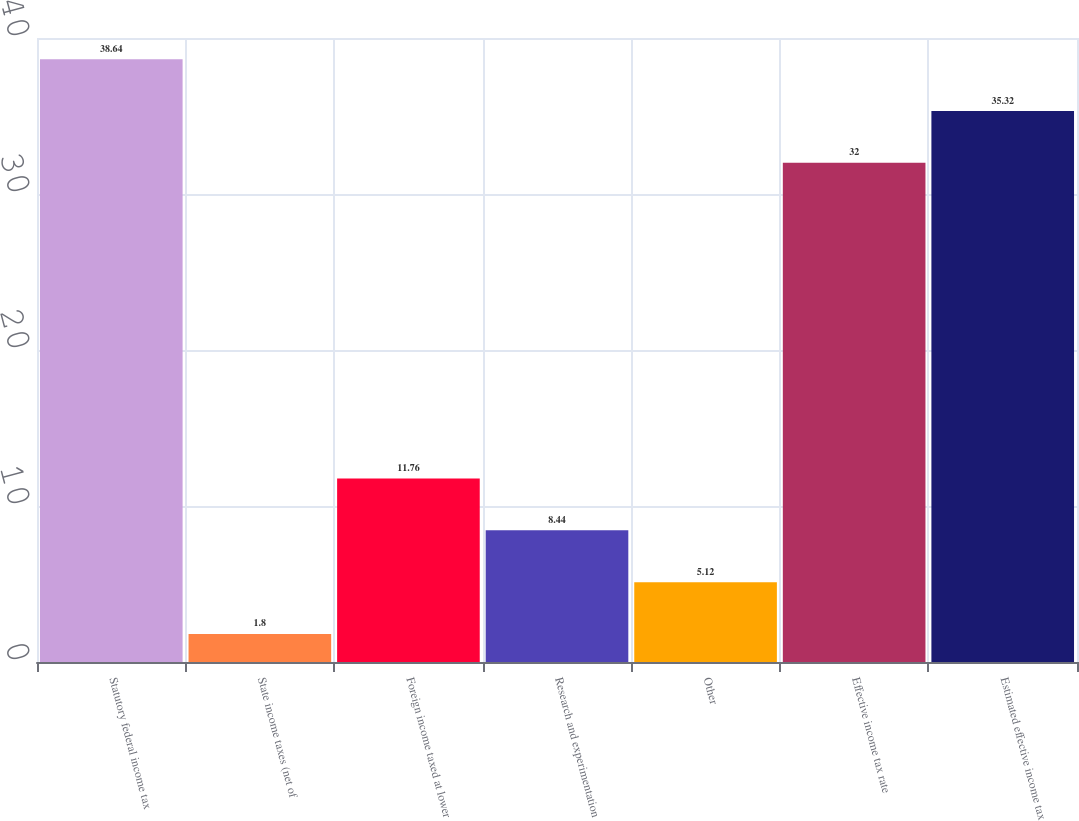Convert chart to OTSL. <chart><loc_0><loc_0><loc_500><loc_500><bar_chart><fcel>Statutory federal income tax<fcel>State income taxes (net of<fcel>Foreign income taxed at lower<fcel>Research and experimentation<fcel>Other<fcel>Effective income tax rate<fcel>Estimated effective income tax<nl><fcel>38.64<fcel>1.8<fcel>11.76<fcel>8.44<fcel>5.12<fcel>32<fcel>35.32<nl></chart> 